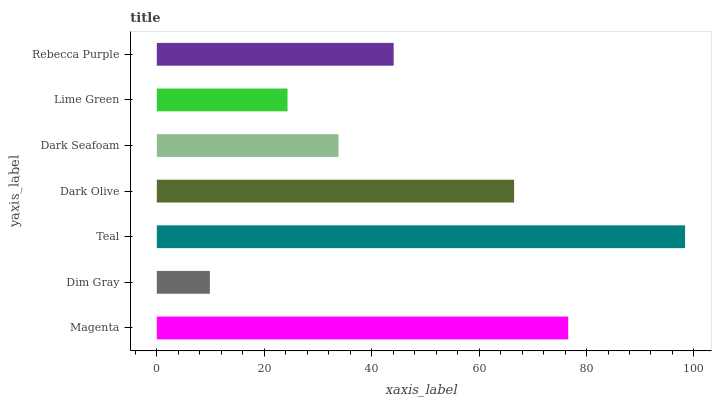Is Dim Gray the minimum?
Answer yes or no. Yes. Is Teal the maximum?
Answer yes or no. Yes. Is Teal the minimum?
Answer yes or no. No. Is Dim Gray the maximum?
Answer yes or no. No. Is Teal greater than Dim Gray?
Answer yes or no. Yes. Is Dim Gray less than Teal?
Answer yes or no. Yes. Is Dim Gray greater than Teal?
Answer yes or no. No. Is Teal less than Dim Gray?
Answer yes or no. No. Is Rebecca Purple the high median?
Answer yes or no. Yes. Is Rebecca Purple the low median?
Answer yes or no. Yes. Is Dark Olive the high median?
Answer yes or no. No. Is Dim Gray the low median?
Answer yes or no. No. 